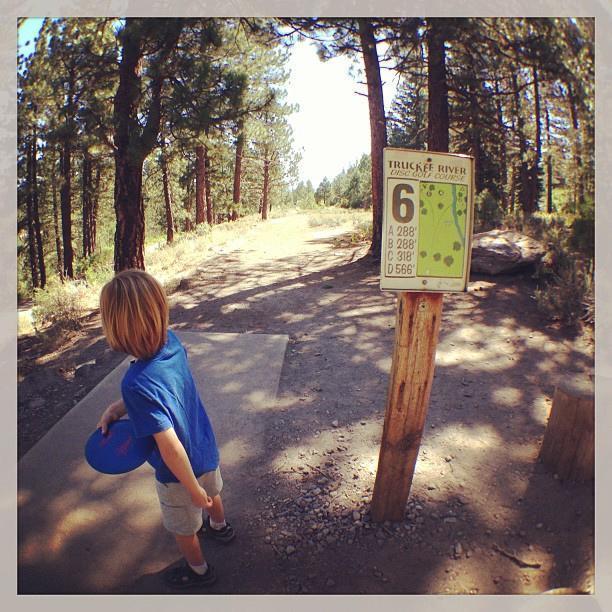How many zebras are here?
Give a very brief answer. 0. 